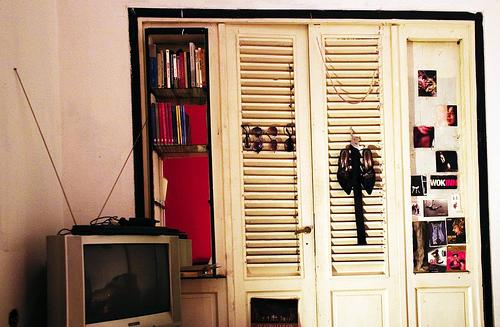Is the TV on?
Quick response, please. No. Is that an LCD TV?
Answer briefly. No. Are there Halloween decorations on the wall?
Give a very brief answer. No. 